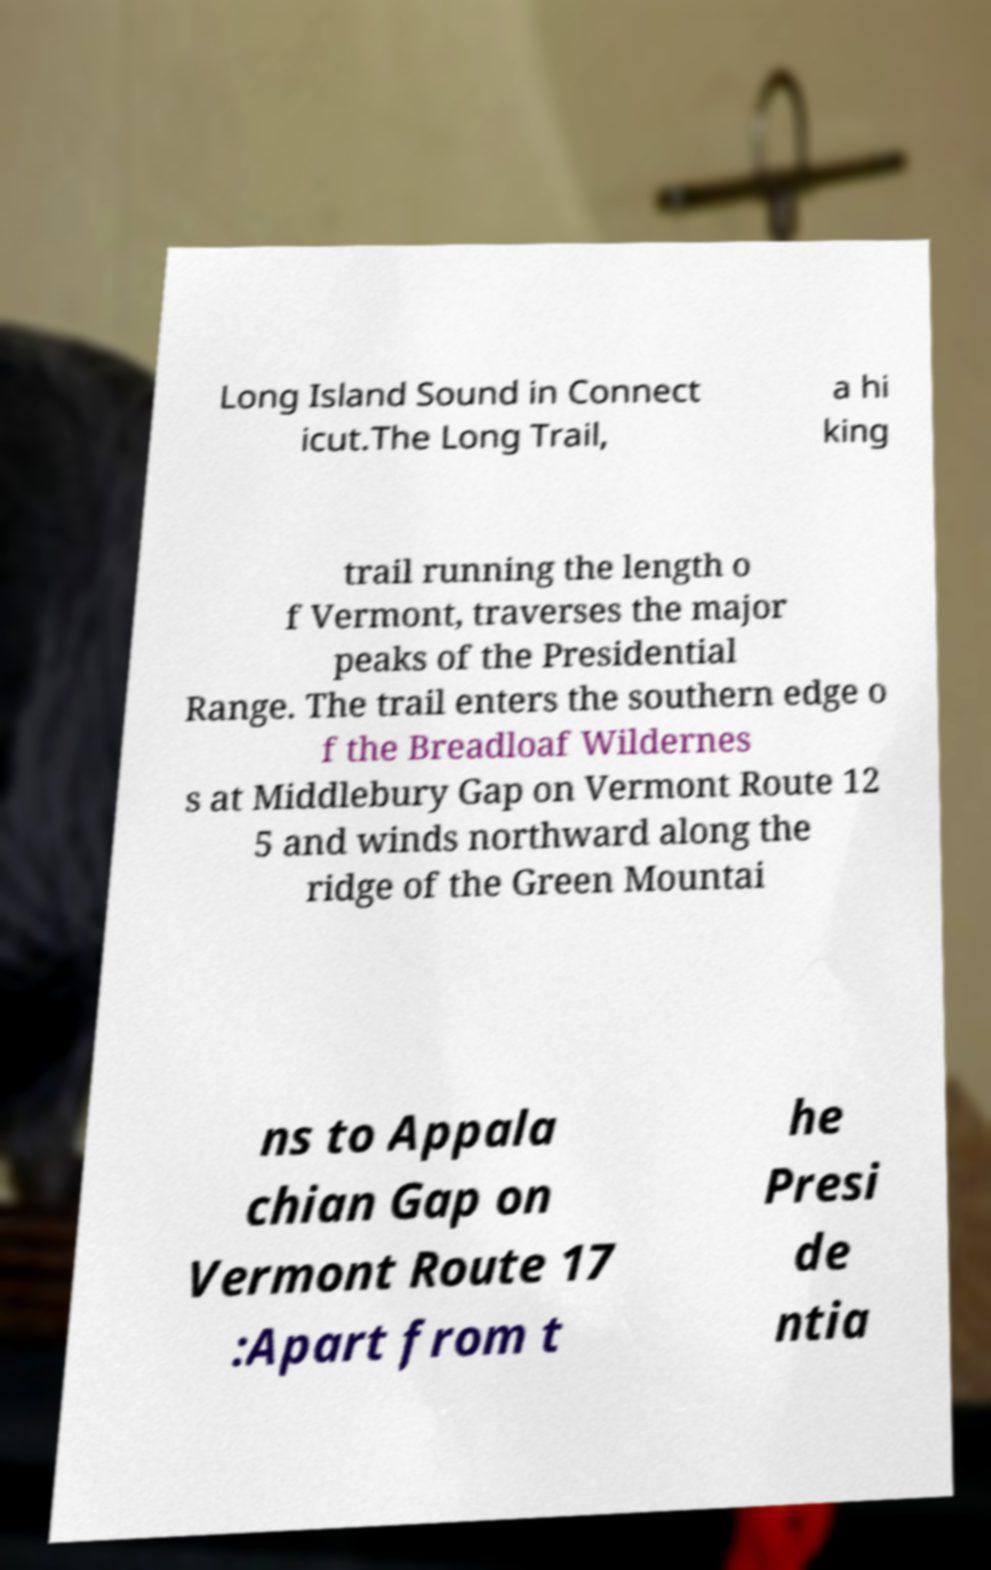There's text embedded in this image that I need extracted. Can you transcribe it verbatim? Long Island Sound in Connect icut.The Long Trail, a hi king trail running the length o f Vermont, traverses the major peaks of the Presidential Range. The trail enters the southern edge o f the Breadloaf Wildernes s at Middlebury Gap on Vermont Route 12 5 and winds northward along the ridge of the Green Mountai ns to Appala chian Gap on Vermont Route 17 :Apart from t he Presi de ntia 